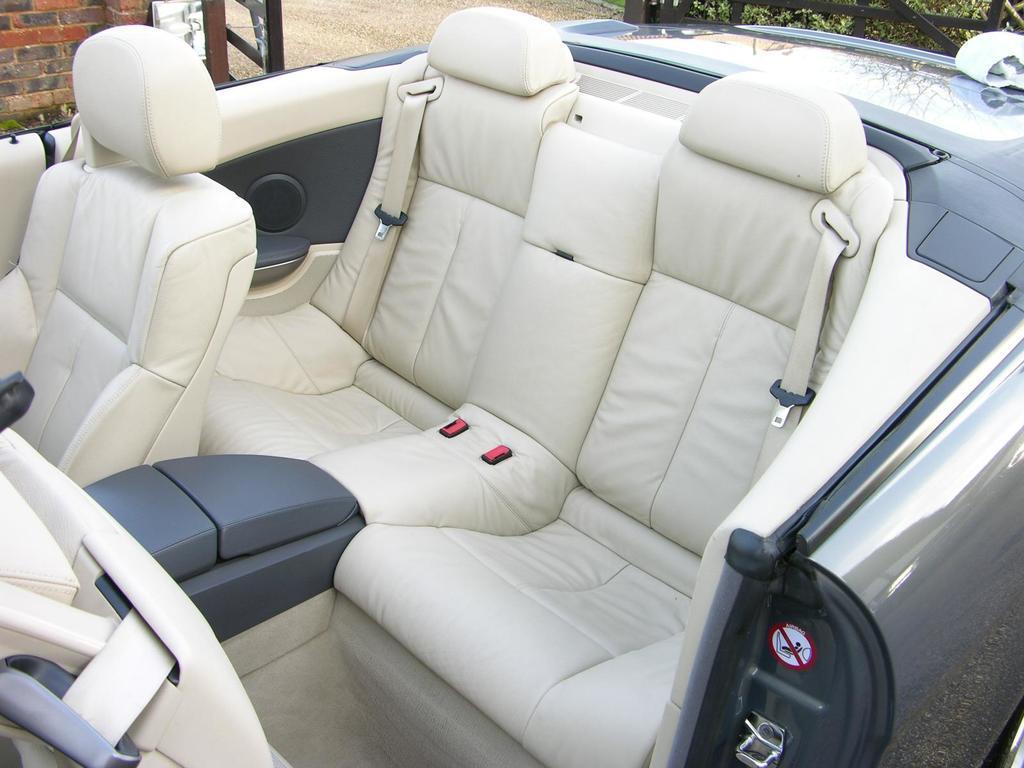In one or two sentences, can you explain what this image depicts? In the foreground of this picture, there is a car and in the background, there are plants, path and the wall. 